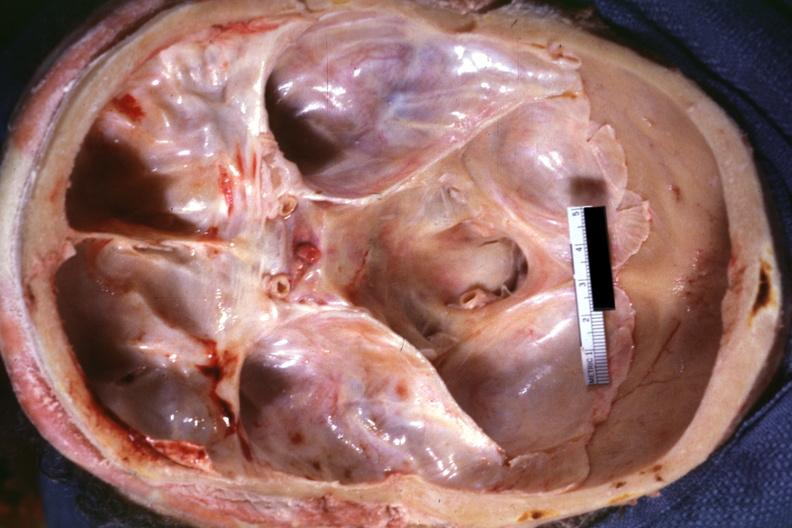what does this image show?
Answer the question using a single word or phrase. View into foramen magnum marked narrowing due to subluxation odontoid process second cervical vertebra 